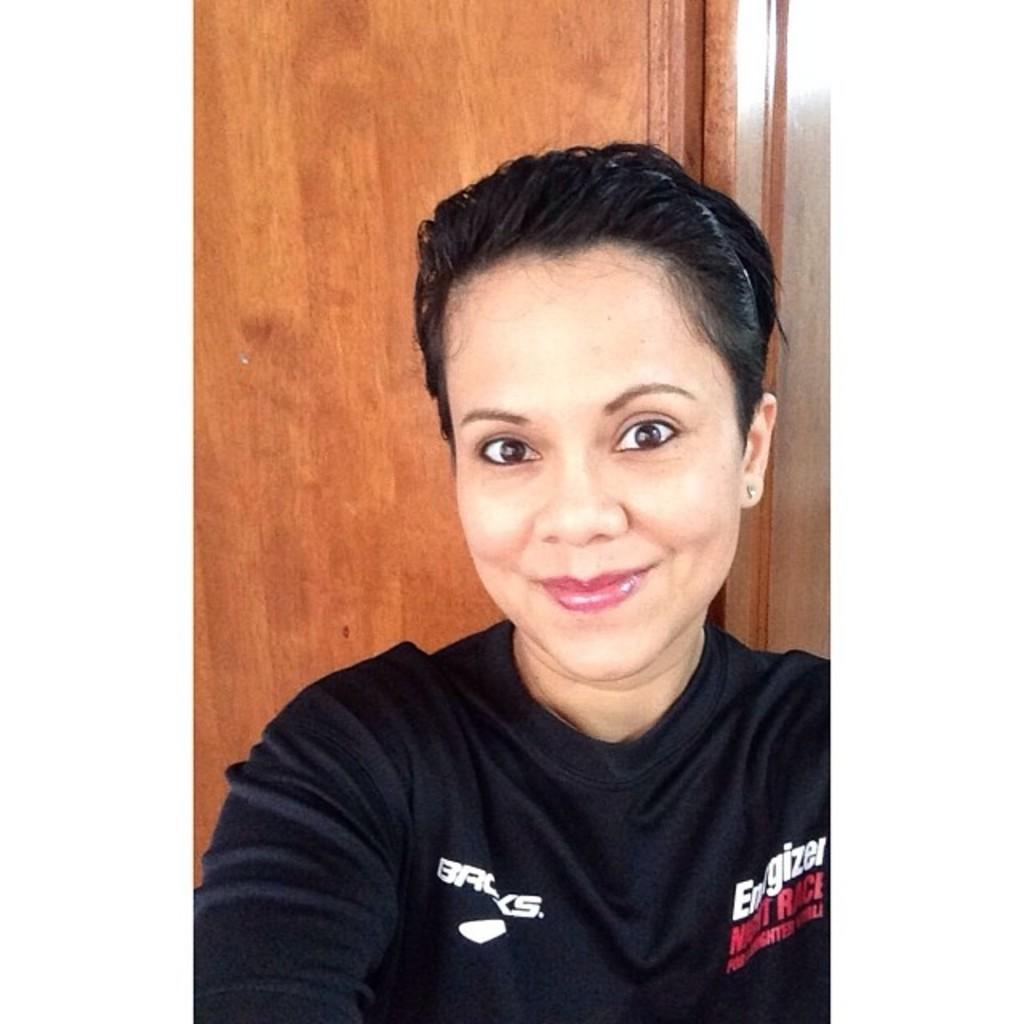Provide a one-sentence caption for the provided image. The shirt is being sponsored by the company Energizer. 